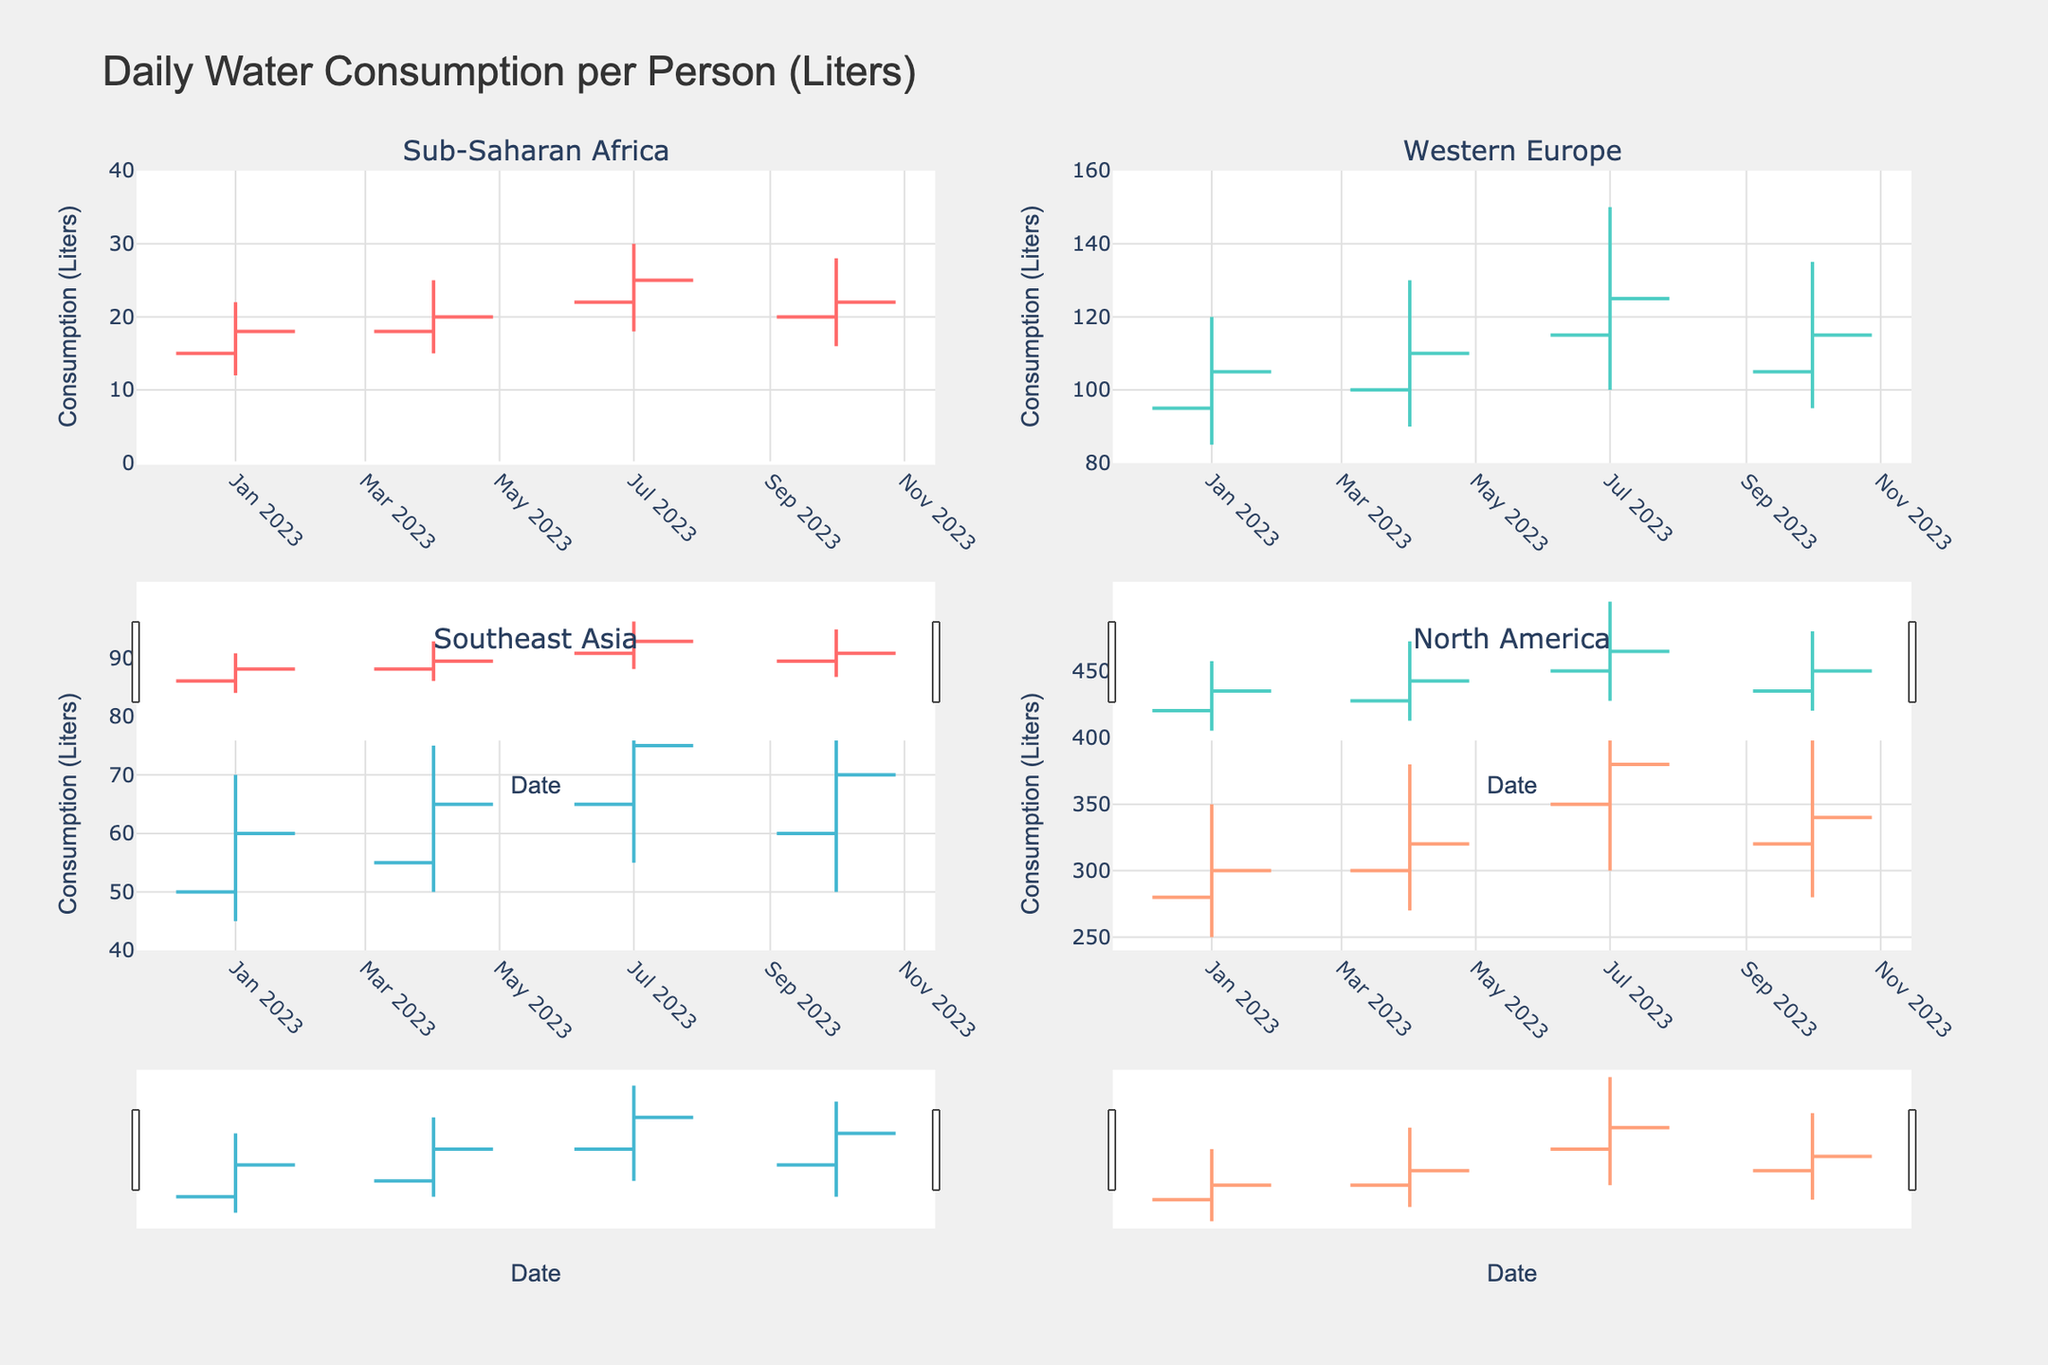What's the highest daily water consumption reported in North America? The graph shows an OHLC chart with the highest values marked for each period. For North America, the highest value is in July 2023 with 450 liters.
Answer: 450 liters Which region has the lowest variability in daily water consumption values? By examining the highest and lowest points in each region's subplot, Western Europe and Sub-Saharan Africa show less spread between high and low values compared to North America and Southeast Asia. Western Europe has less variability.
Answer: Western Europe During which month does Southeast Asia see the highest increase in water consumption? By comparing the open and close values over the months, the largest increase occurs in July 2023 with values opening at 65 and closing at 75 liters.
Answer: July 2023 How does the trend in water consumption from January to October differ between North America and Sub-Saharan Africa? North America shows an increasing trend reaching its peak in July and then decreases but remains high. Sub-Saharan Africa has smaller increments and shows a trend that slightly increases and then dips in October.
Answer: North America generally increases more significantly than Sub-Saharan Africa Which quarter shows the largest drop in water consumption in Western Europe? By examining the open and close values, the largest drop is observed in the October quarter where it opens at 105 liters and closes at 115 liters, compared to the July quarter, showing an end drop.
Answer: October What is the average of the highest daily water consumption values for Sub-Saharan Africa over the year? Summing the high values for each quarter (22+25+30+28) and dividing by 4 gives (105/4).
Answer: 26.25 liters Which region has the highest spread between the highest and lowest water consumption values in October? The spread can be found by subtracting the low value from the high for October. For each region, they are Sub-Saharan Africa (28-16=12), Western Europe (135-95=40), Southeast Asia (80-50=30), and North America (400-280=120). North America has the highest spread.
Answer: North America Is there any region where the close value is consistently higher than the open value? By observing the close and open values quarter-wise, Southeast Asia's close values are consistently higher than its open values in each quarter.
Answer: Southeast Asia 